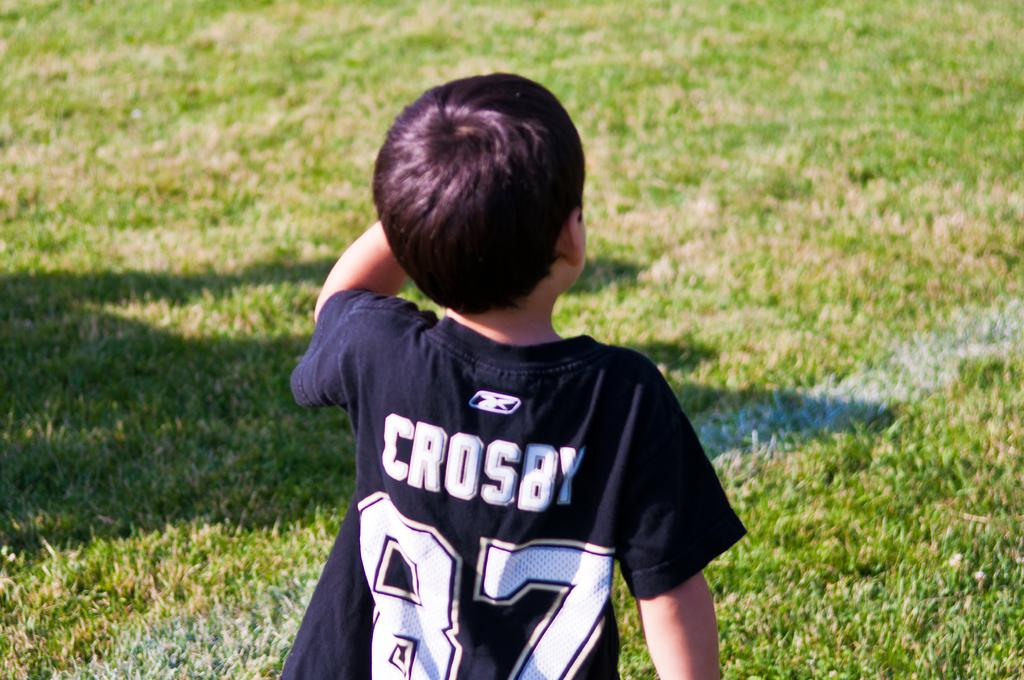Provide a one-sentence caption for the provided image. A young boy in jersey with the name Crosby on the back. 